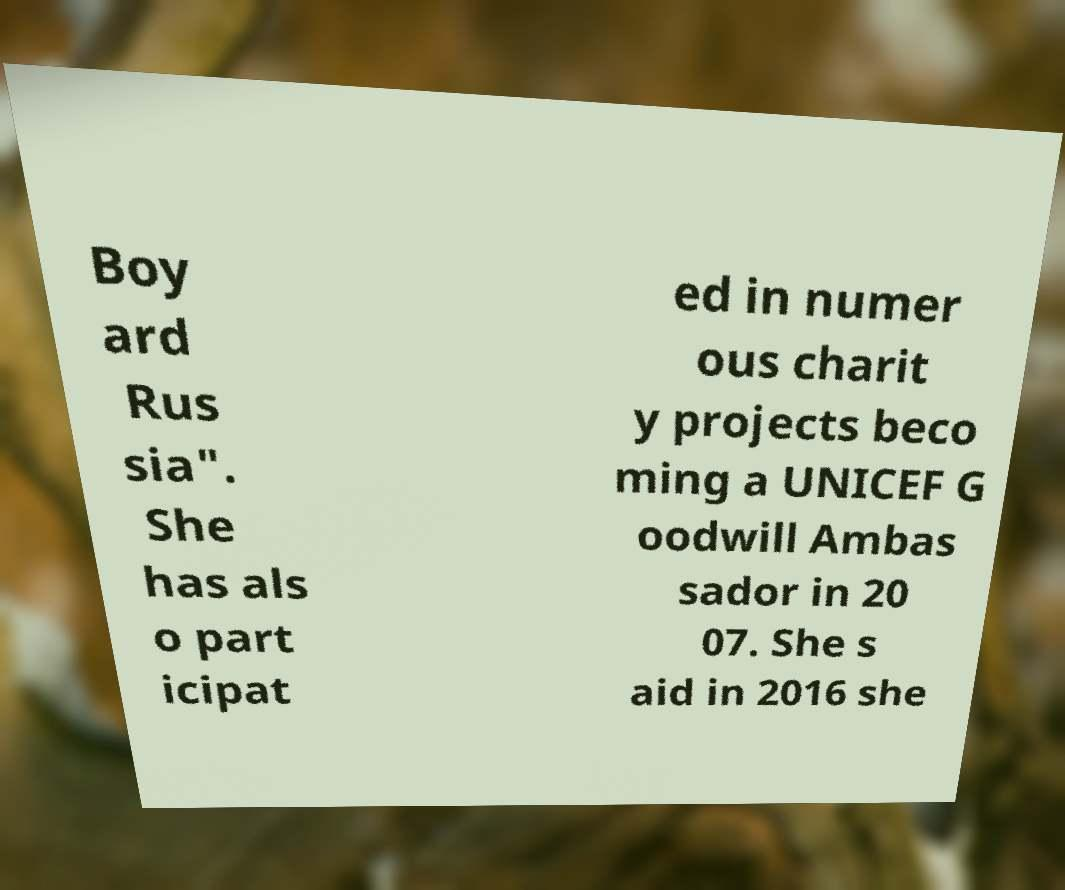For documentation purposes, I need the text within this image transcribed. Could you provide that? Boy ard Rus sia". She has als o part icipat ed in numer ous charit y projects beco ming a UNICEF G oodwill Ambas sador in 20 07. She s aid in 2016 she 